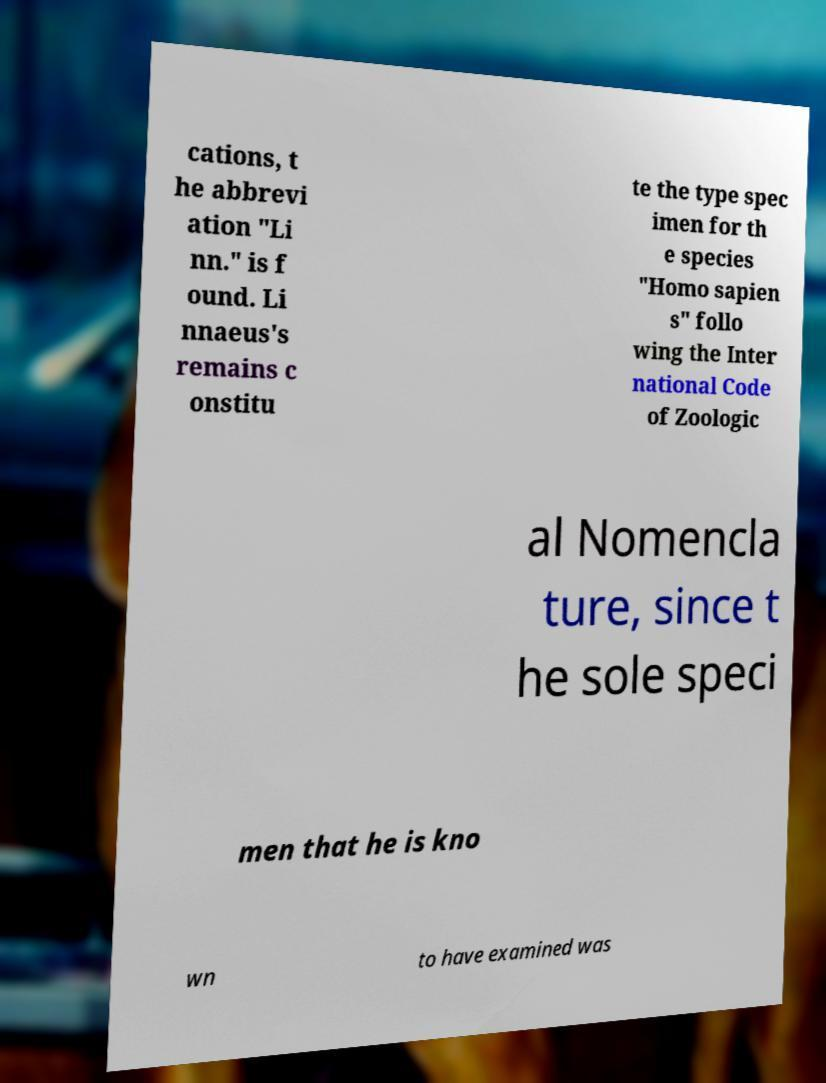Please identify and transcribe the text found in this image. cations, t he abbrevi ation "Li nn." is f ound. Li nnaeus's remains c onstitu te the type spec imen for th e species "Homo sapien s" follo wing the Inter national Code of Zoologic al Nomencla ture, since t he sole speci men that he is kno wn to have examined was 